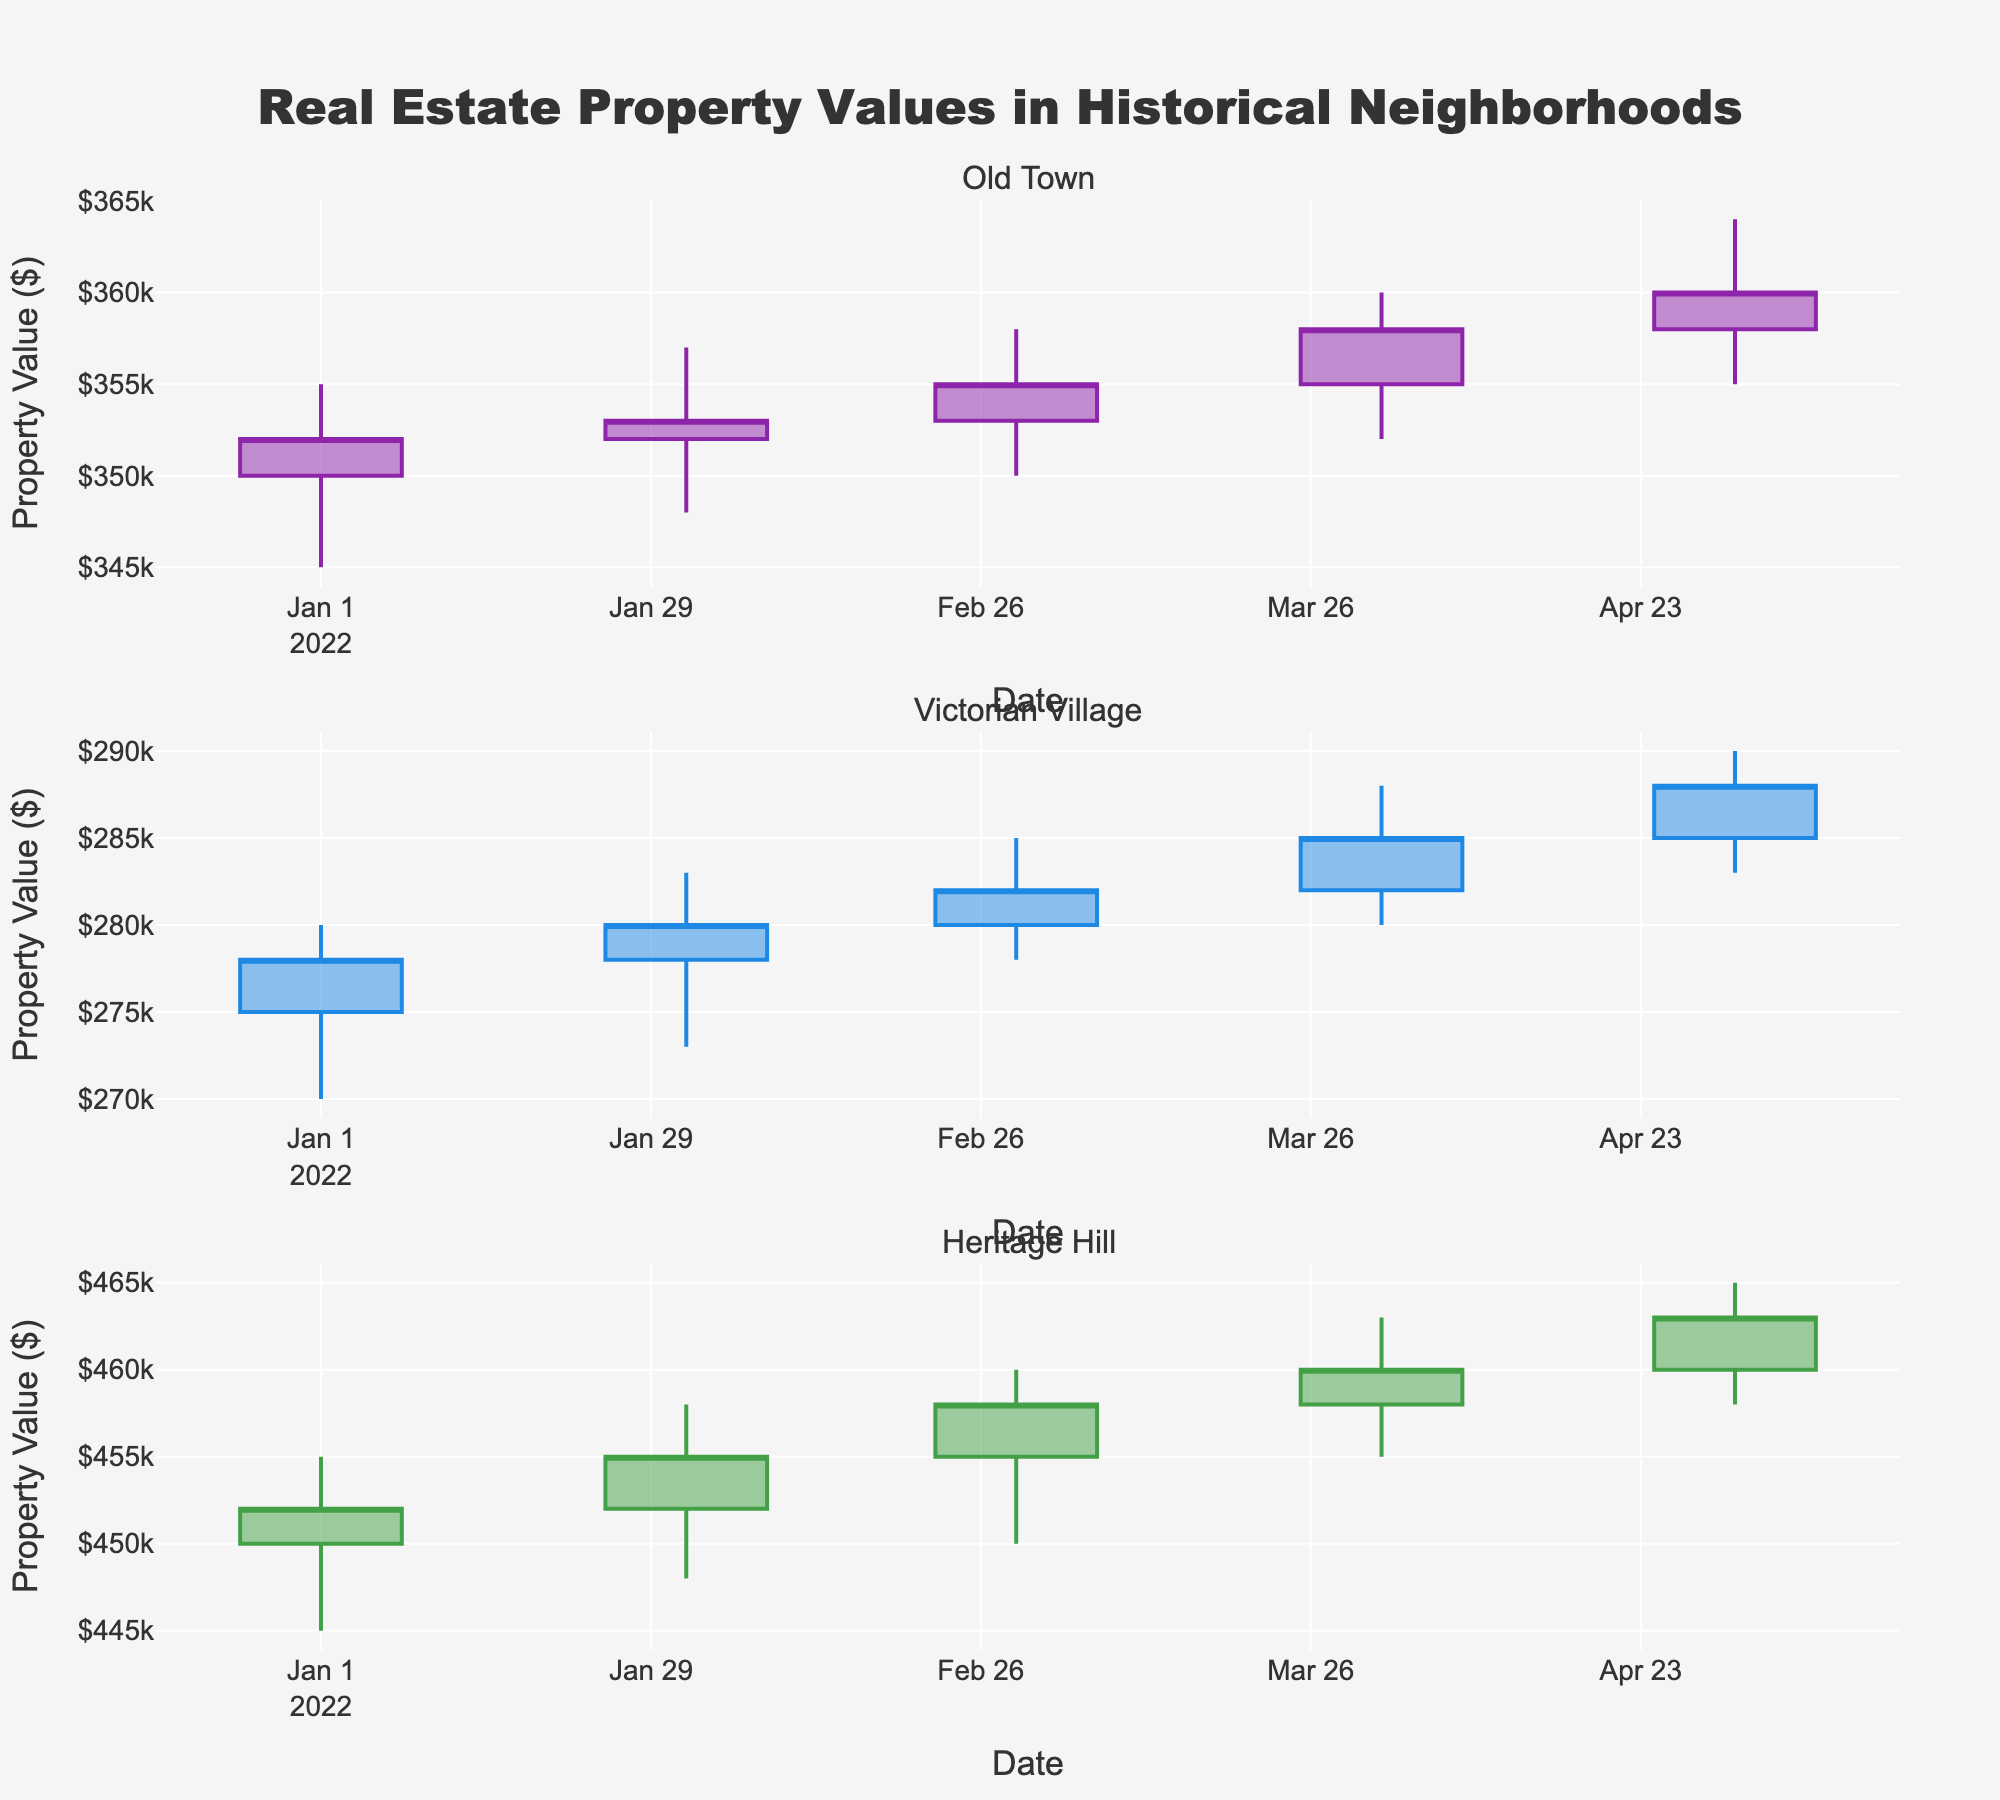Which neighborhood's property values experienced the highest increase from January to May 2022? To find the neighborhood with the highest increase, look at the difference between Close values for January and May. Old Town increased from 352,000 to 360,000, Victorian Village from 278,000 to 288,000, and Heritage Hill from 452,000 to 463,000. The highest increase is from Old Town.
Answer: Old Town What was the closing value of Heritage Hill properties in February 2022? Look at the February 2022 candlestick for Heritage Hill and note the close value at the end. It shows 455,000.
Answer: 455,000 Between Old Town and Victorian Village, which neighborhood had higher property values in each month? Compare the Close values for each month and observe that Old Town's values are consistently higher than those of Victorian Village across all months.
Answer: Old Town During which month did Victorian Village experience the highest range between the high and low values? Calculate the range (high - low) for each month. January has a range of 10,000, February 10,000, March 7,000, April 8,000, and May 7,000. The highest range is in February.
Answer: February What is the average closing price of properties in Heritage Hill over the given months? Sum the closing prices of Heritage Hill from January to May (452,000 + 455,000 + 458,000 + 460,000 + 463,000 = 2,288,000) and divide by 5 months.
Answer: 457,600 What trend can be observed in Old Town's property values from January to May? Examine the candlestick plots for Old Town from January to May. Notice that the closing values show an upward trend, indicating an increase in property values.
Answer: Upward How does the closing price of Victorian Village in May compare with that of March? Compare the candlestick plots for March and May in Victorian Village. March closes at 282,000, and May at 288,000, showing an increase of 6,000.
Answer: Increase Which neighborhood showed the lowest volatility in property prices throughout the timeframe? Look at the range (high - low) for each neighborhood. Heritage Hill ranges are consistently around 10,000, Old Town's around 13,000-14,000, and Victorian Village around 7,000-10,000. Victorian Village shows the lowest volatility generally.
Answer: Victorian Village In April 2022, did any neighborhood experience a decrease in property values compared to March 2022? Compare the closing values from March to April for each neighborhood. All show an increase: Old Town (355,000 to 358,000), Victorian Village (282,000 to 285,000), and Heritage Hill (458,000 to 460,000), so no decrease is observed.
Answer: No What can be inferred about the real estate market in historically important neighborhoods overall? From the candlestick plots, it can be observed that despite some volatility, the overall trend for all neighborhoods is an increase in property values from January to May 2022, indicating a positive growth in the market.
Answer: Positive growth 